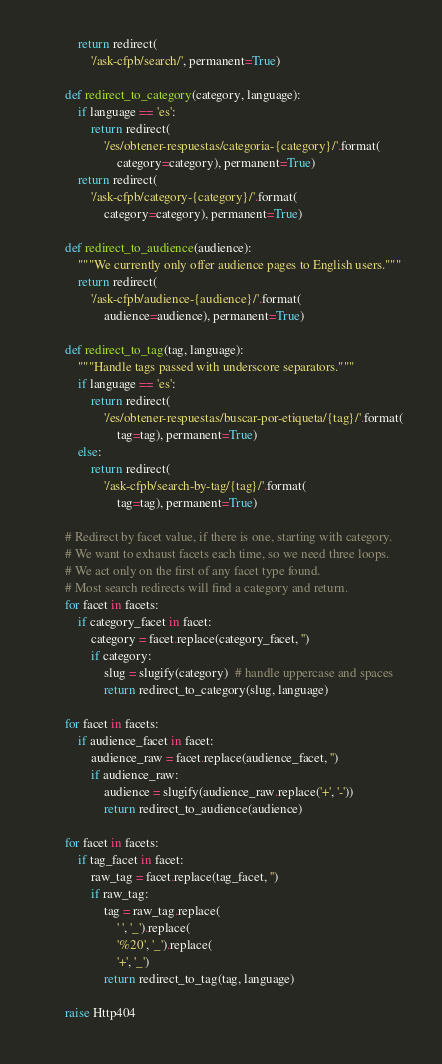Convert code to text. <code><loc_0><loc_0><loc_500><loc_500><_Python_>            return redirect(
                '/ask-cfpb/search/', permanent=True)

        def redirect_to_category(category, language):
            if language == 'es':
                return redirect(
                    '/es/obtener-respuestas/categoria-{category}/'.format(
                        category=category), permanent=True)
            return redirect(
                '/ask-cfpb/category-{category}/'.format(
                    category=category), permanent=True)

        def redirect_to_audience(audience):
            """We currently only offer audience pages to English users."""
            return redirect(
                '/ask-cfpb/audience-{audience}/'.format(
                    audience=audience), permanent=True)

        def redirect_to_tag(tag, language):
            """Handle tags passed with underscore separators."""
            if language == 'es':
                return redirect(
                    '/es/obtener-respuestas/buscar-por-etiqueta/{tag}/'.format(
                        tag=tag), permanent=True)
            else:
                return redirect(
                    '/ask-cfpb/search-by-tag/{tag}/'.format(
                        tag=tag), permanent=True)

        # Redirect by facet value, if there is one, starting with category.
        # We want to exhaust facets each time, so we need three loops.
        # We act only on the first of any facet type found.
        # Most search redirects will find a category and return.
        for facet in facets:
            if category_facet in facet:
                category = facet.replace(category_facet, '')
                if category:
                    slug = slugify(category)  # handle uppercase and spaces
                    return redirect_to_category(slug, language)

        for facet in facets:
            if audience_facet in facet:
                audience_raw = facet.replace(audience_facet, '')
                if audience_raw:
                    audience = slugify(audience_raw.replace('+', '-'))
                    return redirect_to_audience(audience)

        for facet in facets:
            if tag_facet in facet:
                raw_tag = facet.replace(tag_facet, '')
                if raw_tag:
                    tag = raw_tag.replace(
                        ' ', '_').replace(
                        '%20', '_').replace(
                        '+', '_')
                    return redirect_to_tag(tag, language)

        raise Http404
</code> 